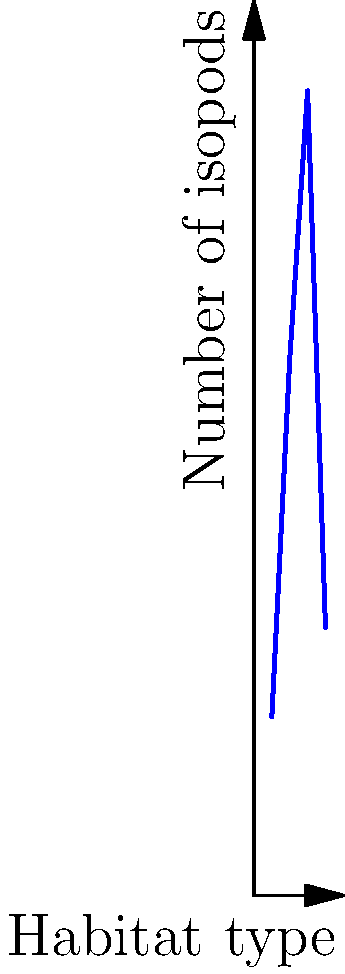The graph shows the distribution of isopods across different habitats. Based on the data, which habitat type supports the highest isopod population, and what is the approximate number of isopods found in that habitat? To answer this question, we need to analyze the given Cartesian coordinate system:

1. The x-axis represents different habitat types:
   x = 1: Leaf litter
   x = 2: Rotting wood
   x = 3: Soil
   x = 4: Rock crevices

2. The y-axis represents the number of isopods.

3. Examining the data points:
   - Leaf litter (x = 1): approximately 10 isopods
   - Rotting wood (x = 2): approximately 30 isopods
   - Soil (x = 3): approximately 45 isopods
   - Rock crevices (x = 4): approximately 15 isopods

4. The highest point on the graph corresponds to x = 3 (Soil) and y ≈ 45.

Therefore, the habitat type that supports the highest isopod population is soil, with approximately 45 isopods.
Answer: Soil, 45 isopods 